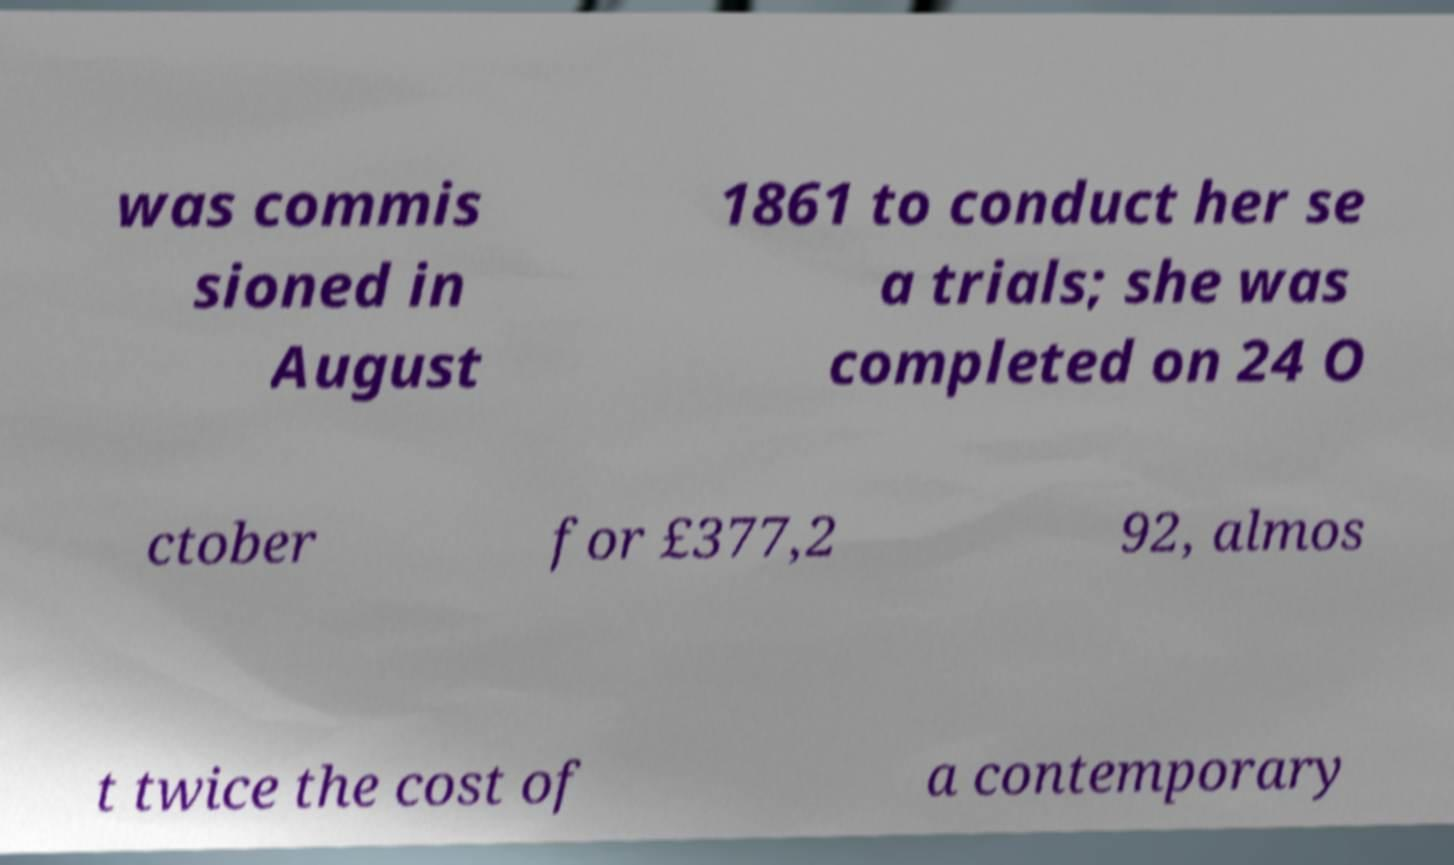Can you accurately transcribe the text from the provided image for me? was commis sioned in August 1861 to conduct her se a trials; she was completed on 24 O ctober for £377,2 92, almos t twice the cost of a contemporary 